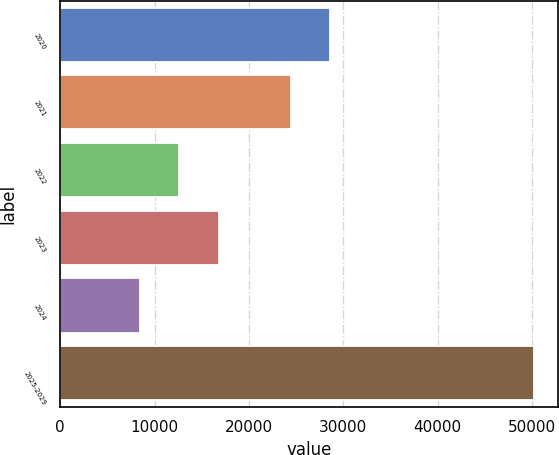Convert chart to OTSL. <chart><loc_0><loc_0><loc_500><loc_500><bar_chart><fcel>2020<fcel>2021<fcel>2022<fcel>2023<fcel>2024<fcel>2025-2029<nl><fcel>28581.7<fcel>24407<fcel>12614.7<fcel>16789.4<fcel>8440<fcel>50187<nl></chart> 